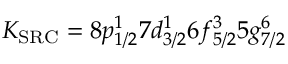Convert formula to latex. <formula><loc_0><loc_0><loc_500><loc_500>K _ { S R C } = 8 p _ { 1 / 2 } ^ { 1 } 7 d _ { 3 / 2 } ^ { 1 } 6 f _ { 5 / 2 } ^ { 3 } 5 g _ { 7 / 2 } ^ { 6 }</formula> 